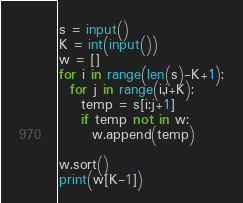Convert code to text. <code><loc_0><loc_0><loc_500><loc_500><_Python_>s = input()
K = int(input())
w = []
for i in range(len(s)-K+1):
  for j in range(i,i+K):
    temp = s[i:j+1]
    if temp not in w:
      w.append(temp)
      
w.sort()
print(w[K-1])</code> 